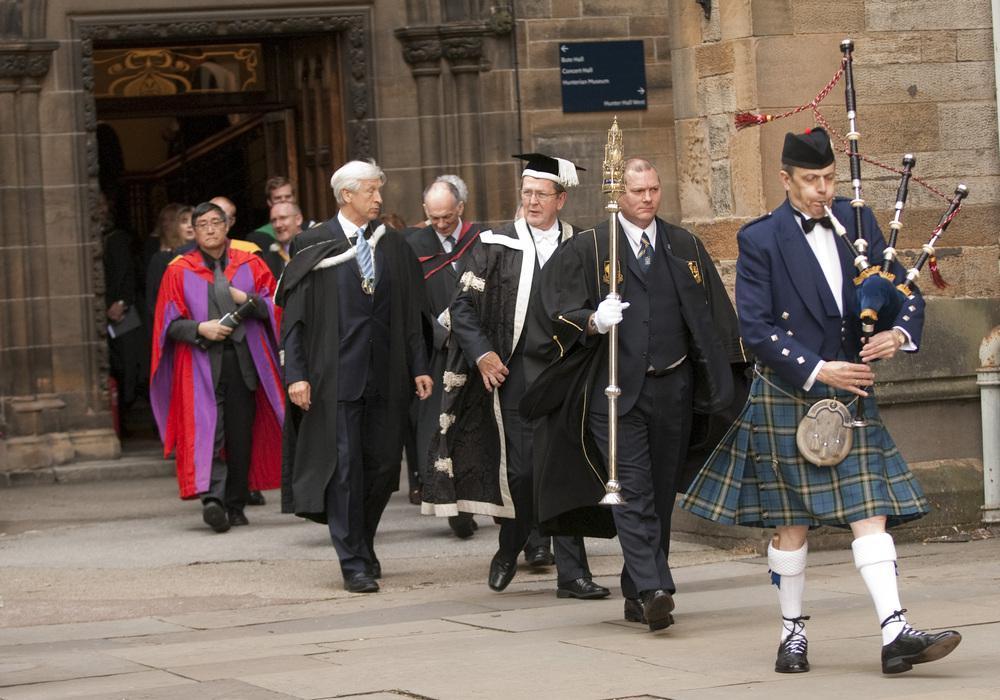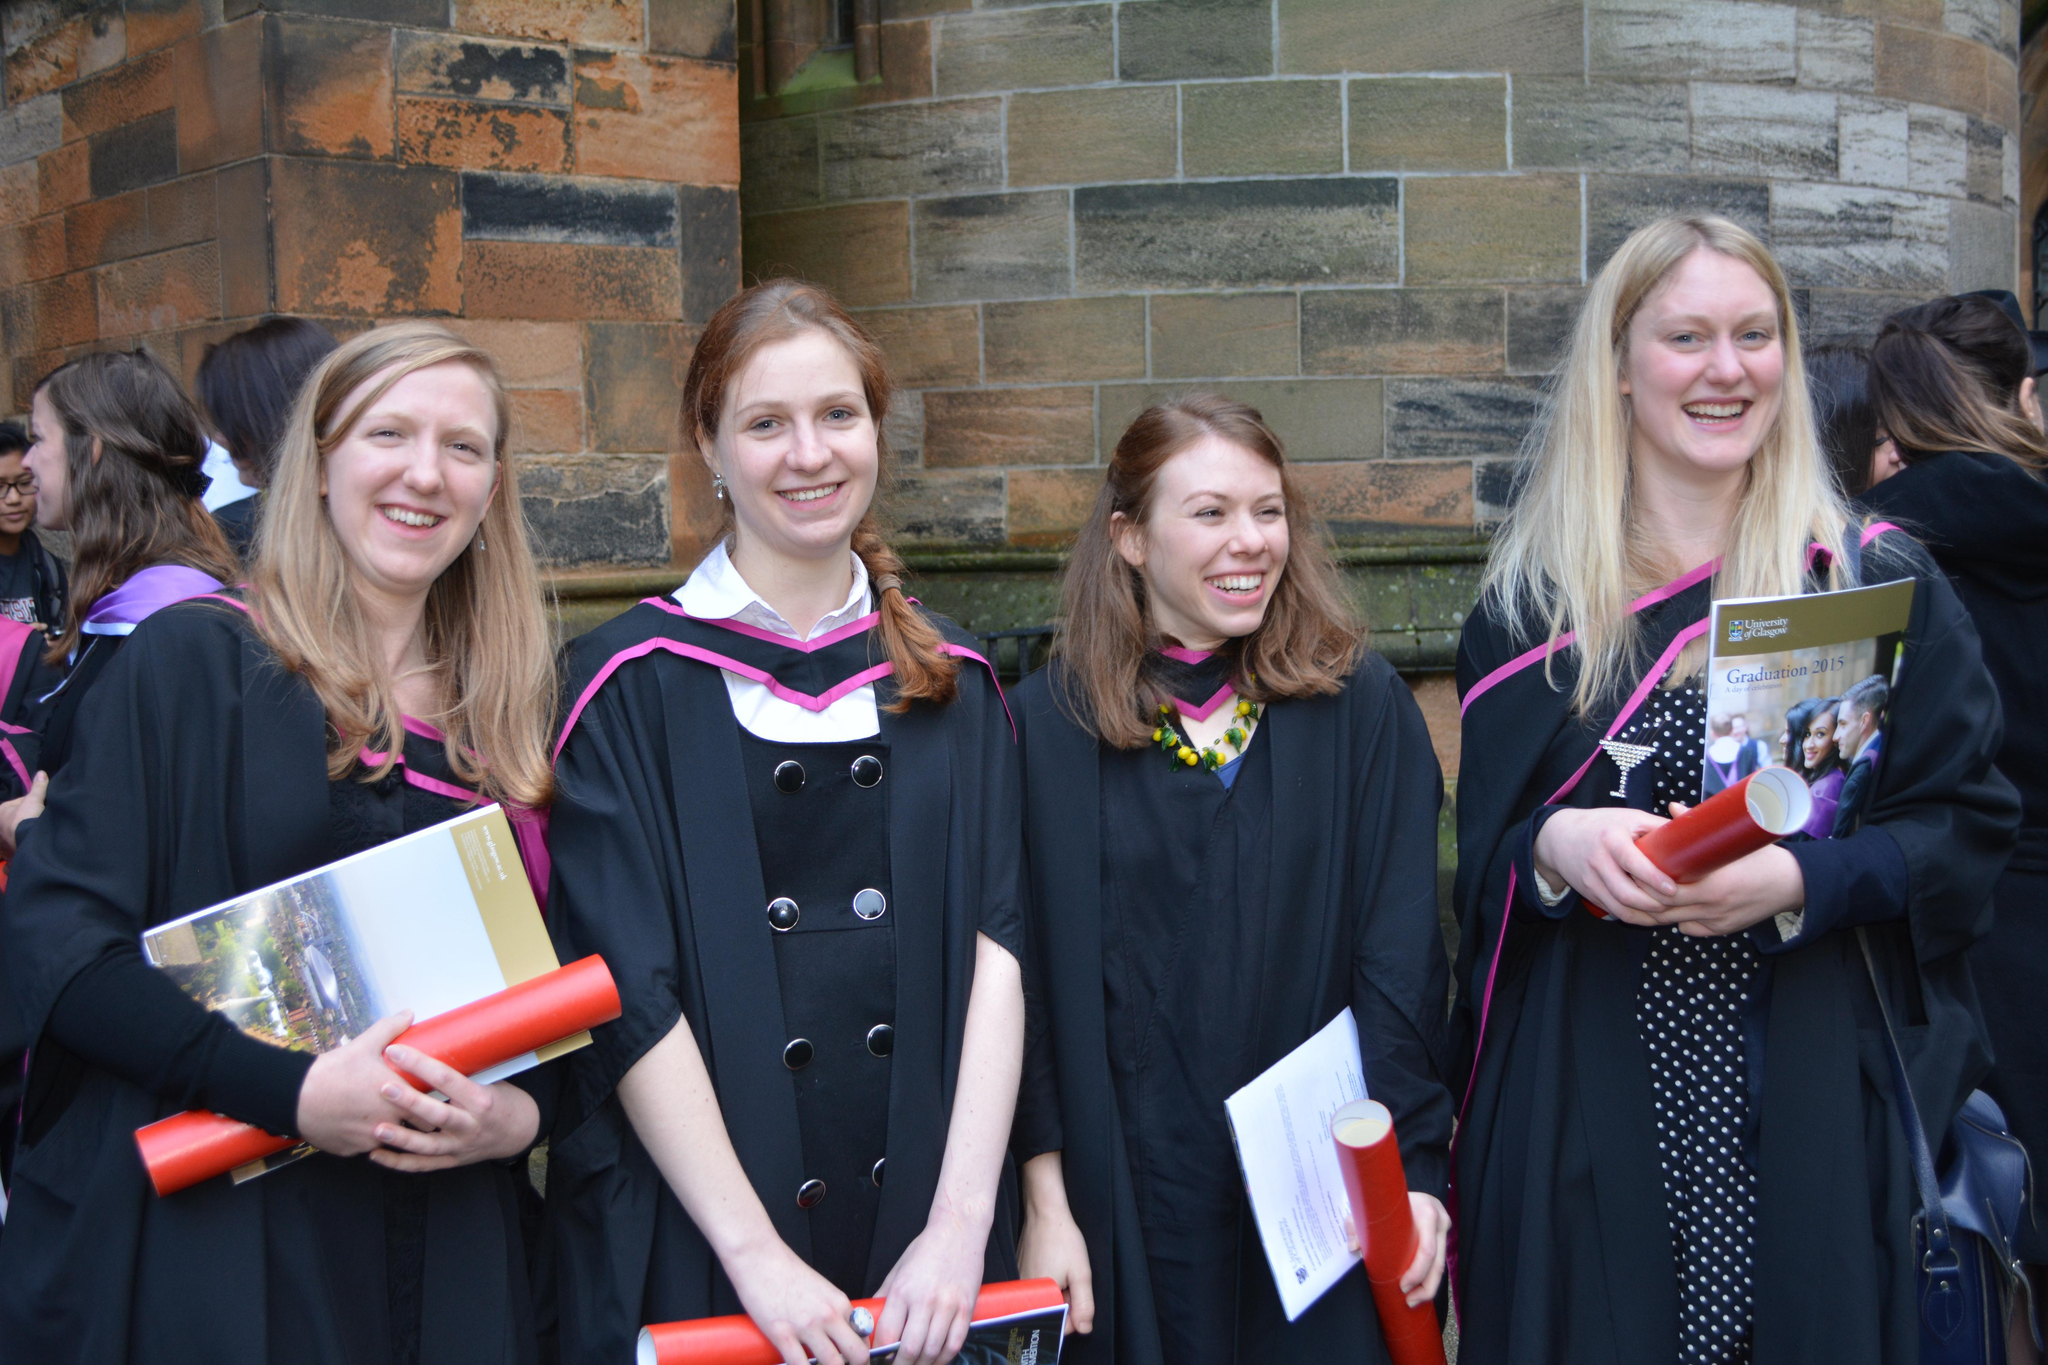The first image is the image on the left, the second image is the image on the right. For the images shown, is this caption "At least four graduates are holding red diploma tubes." true? Answer yes or no. Yes. The first image is the image on the left, the second image is the image on the right. Assess this claim about the two images: "At least four people hold red tube shapes and wear black robes in the foreground of one image.". Correct or not? Answer yes or no. Yes. 